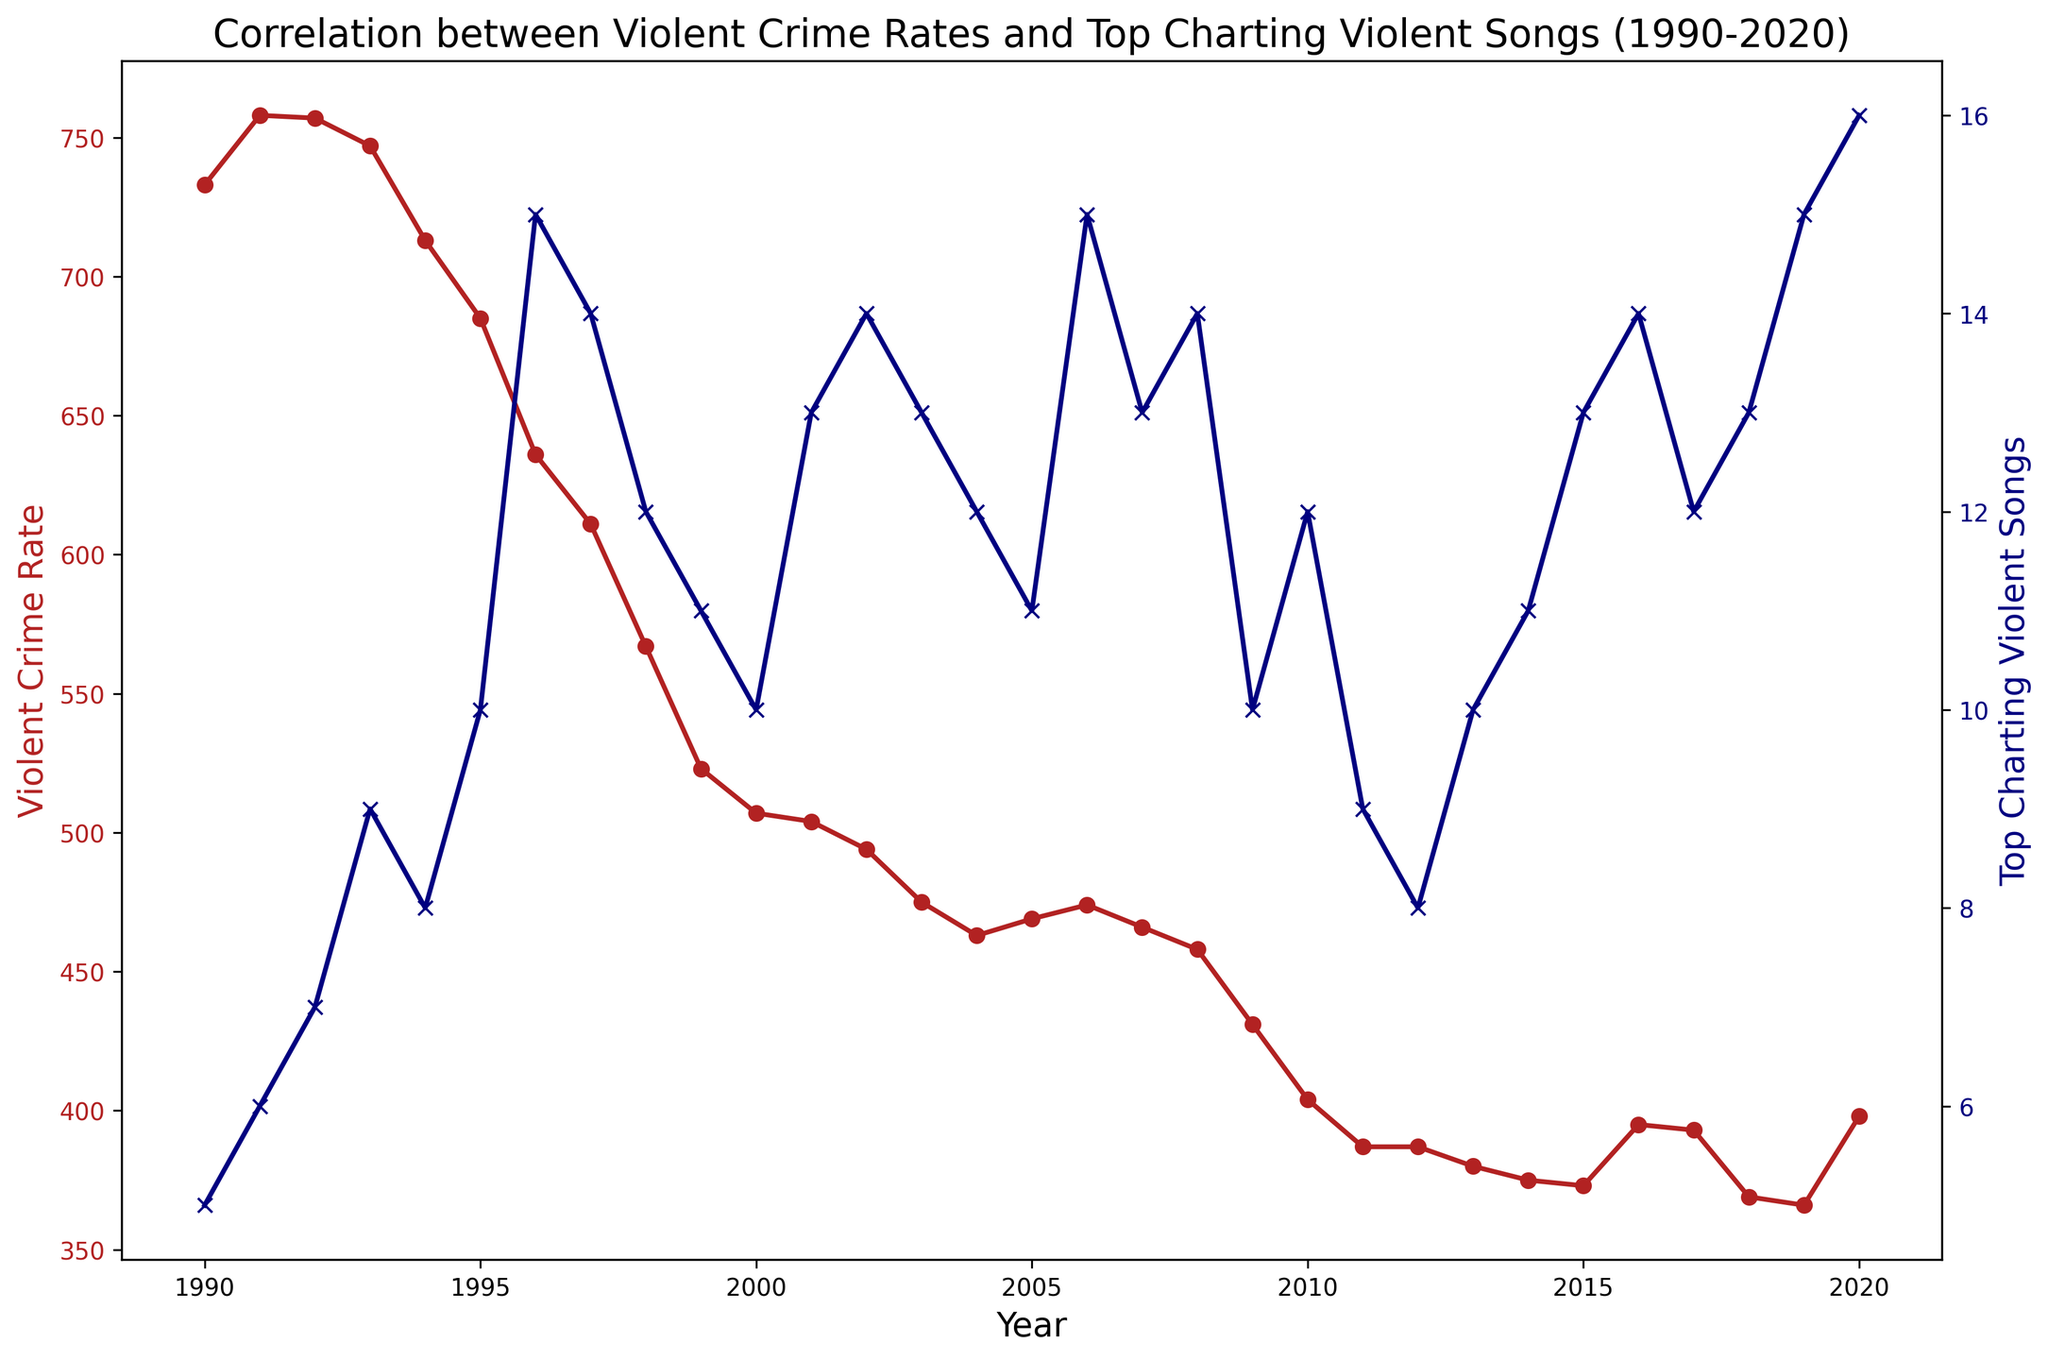Which year had the highest violent crime rate? The plot shows the violent crime rate (represented as a red line). Determine which point on the red line is the highest.
Answer: 1991 In which years did the violent crime rate and the number of top-charting violent songs both increase compared to the previous year? Examine the trends where both the red line (violent crime rate) and the blue line (top-charting violent songs) have an upward direction from year to year.
Answer: 2006, 2008, 2015 By how much did the violent crime rate decrease from 1990 to 2010? Subtract the violent crime rate in 2010 from the rate in 1990 (733 - 404).
Answer: 329 What is the visual difference between the lines representing the violent crime rate and top-charting violent songs over the 30-year span? Observe the red (violent crime rate) and blue (top-charting violent songs) lines. The red line generally declines while the blue line has less consistent fluctuations with periods of increase and decrease.
Answer: Declining vs. fluctuating Were there any years when the violent crime rate increased but the number of top-charting violent songs decreased? Identify the years where the red line trends upward while the blue line trends downward.
Answer: 2016 Find the year with the highest number of top-charting violent songs and state the violent crime rate for that year. Locate the highest point on the blue line (top-charting violent songs) and find the corresponding value on the red line (violent crime rate) in the same year.
Answer: 2020, 398 What was the average number of top-charting violent songs from 1995 to 2000? Add the number of top-charting violent songs from 1995 to 2000 and divide by the number of years (10 + 15 + 14 + 12 + 11 + 10) / 6.
Answer: 12 How does the violent crime rate change from 1990 to 2020 compared to the trend in top-charting violent songs over the same period? Describe if each trend line (red for violent crime rate and blue for top-charting violent songs) increases or decreases over these years. The violent crime rate sharply decreases, while the number of top-charting violent songs shows an overall slightly increasing trend.
Answer: Decreases vs. Slightly Increases Which year experienced the largest one-year decrease in the violent crime rate? Determine the most significant drop by comparing consecutive years on the red line and finding the largest difference.
Answer: 1996 When did the number of top-charting violent songs reach 15 for the first time, and what was the violent crime rate that year? Find the first occurrence of the blue line reaching 15 and check the corresponding red line value.
Answer: 1996, 636 